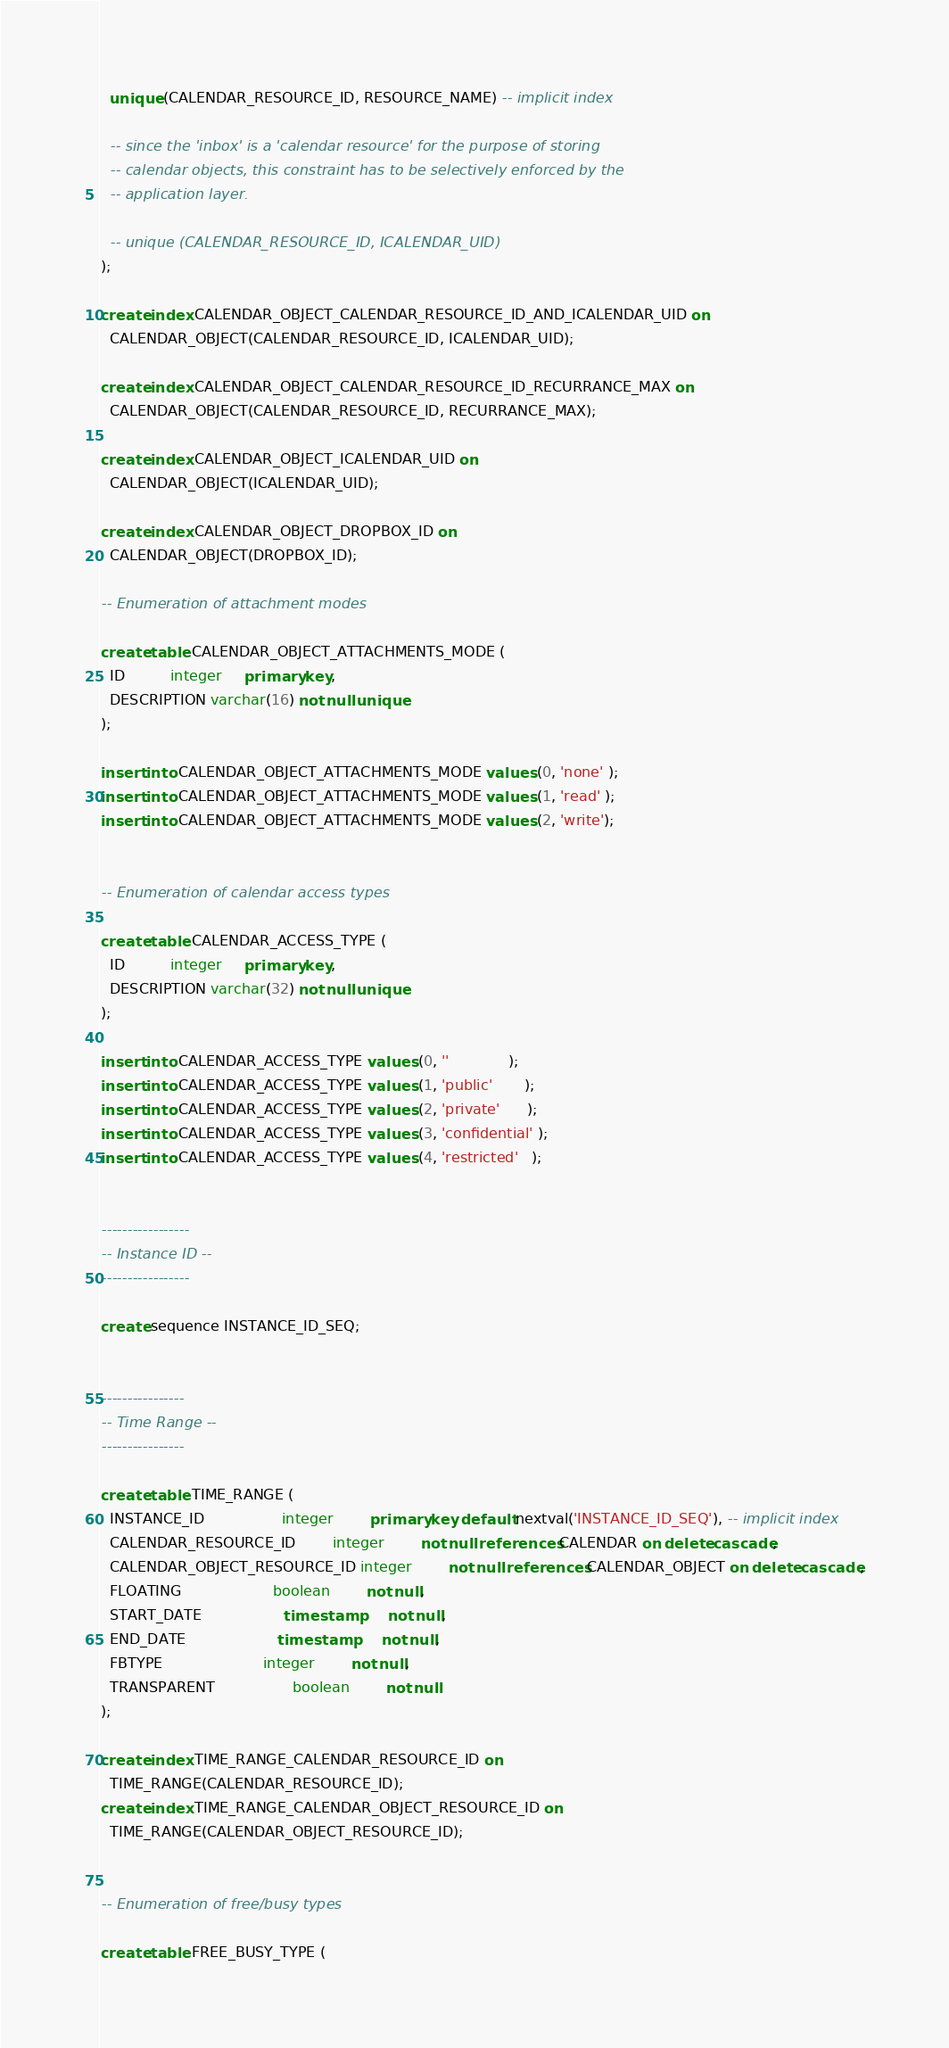<code> <loc_0><loc_0><loc_500><loc_500><_SQL_>
  unique (CALENDAR_RESOURCE_ID, RESOURCE_NAME) -- implicit index

  -- since the 'inbox' is a 'calendar resource' for the purpose of storing
  -- calendar objects, this constraint has to be selectively enforced by the
  -- application layer.

  -- unique (CALENDAR_RESOURCE_ID, ICALENDAR_UID)
);

create index CALENDAR_OBJECT_CALENDAR_RESOURCE_ID_AND_ICALENDAR_UID on
  CALENDAR_OBJECT(CALENDAR_RESOURCE_ID, ICALENDAR_UID);

create index CALENDAR_OBJECT_CALENDAR_RESOURCE_ID_RECURRANCE_MAX on
  CALENDAR_OBJECT(CALENDAR_RESOURCE_ID, RECURRANCE_MAX);

create index CALENDAR_OBJECT_ICALENDAR_UID on
  CALENDAR_OBJECT(ICALENDAR_UID);

create index CALENDAR_OBJECT_DROPBOX_ID on
  CALENDAR_OBJECT(DROPBOX_ID);

-- Enumeration of attachment modes

create table CALENDAR_OBJECT_ATTACHMENTS_MODE (
  ID          integer     primary key,
  DESCRIPTION varchar(16) not null unique
);

insert into CALENDAR_OBJECT_ATTACHMENTS_MODE values (0, 'none' );
insert into CALENDAR_OBJECT_ATTACHMENTS_MODE values (1, 'read' );
insert into CALENDAR_OBJECT_ATTACHMENTS_MODE values (2, 'write');


-- Enumeration of calendar access types

create table CALENDAR_ACCESS_TYPE (
  ID          integer     primary key,
  DESCRIPTION varchar(32) not null unique
);

insert into CALENDAR_ACCESS_TYPE values (0, ''             );
insert into CALENDAR_ACCESS_TYPE values (1, 'public'       );
insert into CALENDAR_ACCESS_TYPE values (2, 'private'      );
insert into CALENDAR_ACCESS_TYPE values (3, 'confidential' );
insert into CALENDAR_ACCESS_TYPE values (4, 'restricted'   );


-----------------
-- Instance ID --
-----------------

create sequence INSTANCE_ID_SEQ;


----------------
-- Time Range --
----------------

create table TIME_RANGE (
  INSTANCE_ID                 integer        primary key default nextval('INSTANCE_ID_SEQ'), -- implicit index
  CALENDAR_RESOURCE_ID        integer        not null references CALENDAR on delete cascade,
  CALENDAR_OBJECT_RESOURCE_ID integer        not null references CALENDAR_OBJECT on delete cascade,
  FLOATING                    boolean        not null,
  START_DATE                  timestamp      not null,
  END_DATE                    timestamp      not null,
  FBTYPE                      integer        not null,
  TRANSPARENT                 boolean        not null
);

create index TIME_RANGE_CALENDAR_RESOURCE_ID on
  TIME_RANGE(CALENDAR_RESOURCE_ID);
create index TIME_RANGE_CALENDAR_OBJECT_RESOURCE_ID on
  TIME_RANGE(CALENDAR_OBJECT_RESOURCE_ID);


-- Enumeration of free/busy types

create table FREE_BUSY_TYPE (</code> 